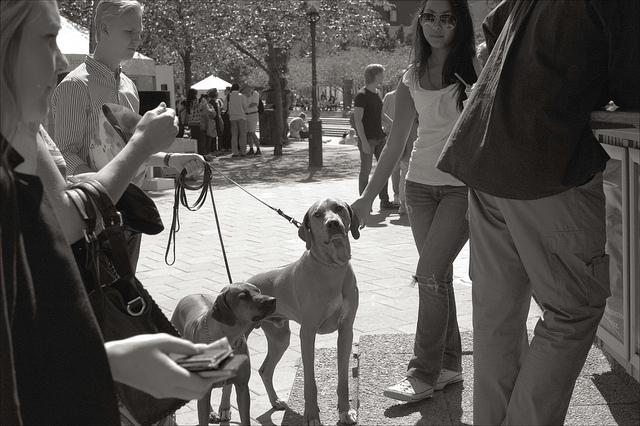In which knee is the hole in the women's pants?
Give a very brief answer. Left. How are the dogs kept close?
Answer briefly. Leash. In which season does this scene take place?
Concise answer only. Summer. 